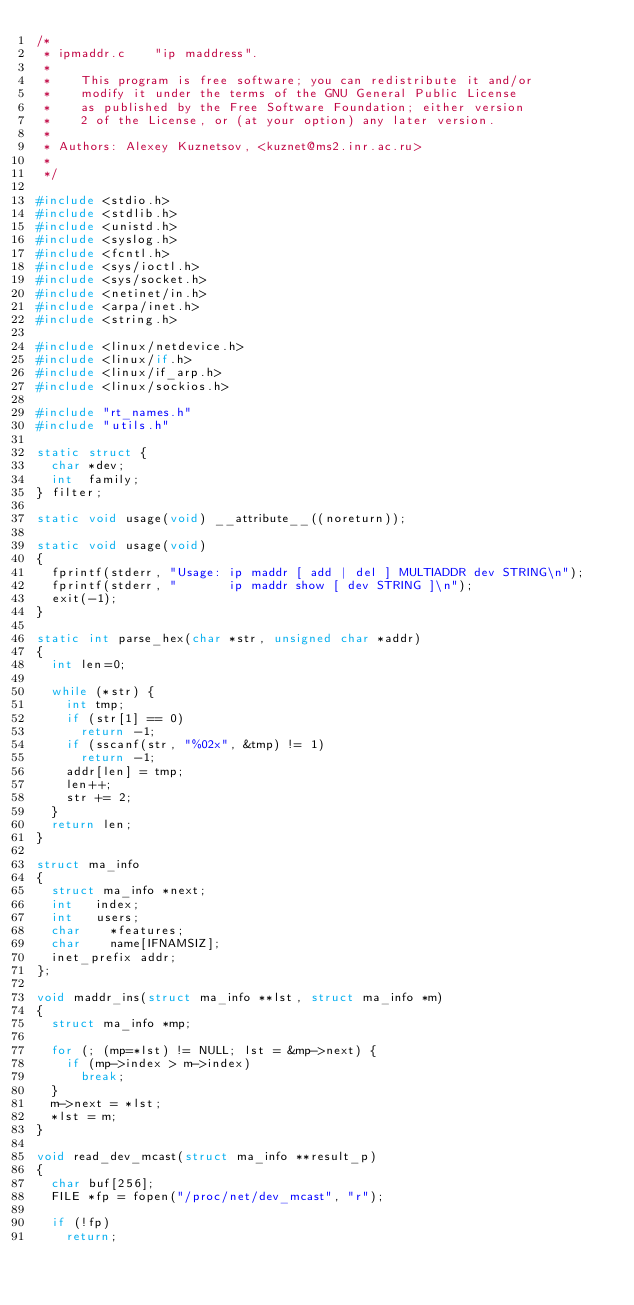Convert code to text. <code><loc_0><loc_0><loc_500><loc_500><_C_>/*
 * ipmaddr.c		"ip maddress".
 *
 *		This program is free software; you can redistribute it and/or
 *		modify it under the terms of the GNU General Public License
 *		as published by the Free Software Foundation; either version
 *		2 of the License, or (at your option) any later version.
 *
 * Authors:	Alexey Kuznetsov, <kuznet@ms2.inr.ac.ru>
 *
 */

#include <stdio.h>
#include <stdlib.h>
#include <unistd.h>
#include <syslog.h>
#include <fcntl.h>
#include <sys/ioctl.h>
#include <sys/socket.h>
#include <netinet/in.h>
#include <arpa/inet.h>
#include <string.h>

#include <linux/netdevice.h>
#include <linux/if.h>
#include <linux/if_arp.h>
#include <linux/sockios.h>

#include "rt_names.h"
#include "utils.h"

static struct {
	char *dev;
	int  family;
} filter;

static void usage(void) __attribute__((noreturn));

static void usage(void)
{
	fprintf(stderr, "Usage: ip maddr [ add | del ] MULTIADDR dev STRING\n");
	fprintf(stderr, "       ip maddr show [ dev STRING ]\n");
	exit(-1);
}

static int parse_hex(char *str, unsigned char *addr)
{
	int len=0;

	while (*str) {
		int tmp;
		if (str[1] == 0)
			return -1;
		if (sscanf(str, "%02x", &tmp) != 1)
			return -1;
		addr[len] = tmp;
		len++;
		str += 2;
	}
	return len;
}

struct ma_info
{
	struct ma_info *next;
	int		index;
	int		users;
	char		*features;
	char		name[IFNAMSIZ];
	inet_prefix	addr;
};

void maddr_ins(struct ma_info **lst, struct ma_info *m)
{
	struct ma_info *mp;

	for (; (mp=*lst) != NULL; lst = &mp->next) {
		if (mp->index > m->index)
			break;
	}
	m->next = *lst;
	*lst = m;
}

void read_dev_mcast(struct ma_info **result_p)
{
	char buf[256];
	FILE *fp = fopen("/proc/net/dev_mcast", "r");

	if (!fp)
		return;
</code> 